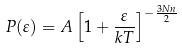Convert formula to latex. <formula><loc_0><loc_0><loc_500><loc_500>P ( \varepsilon ) = A \left [ 1 + \frac { \varepsilon } { k T } \right ] ^ { - \frac { 3 N n } { 2 } } \,</formula> 